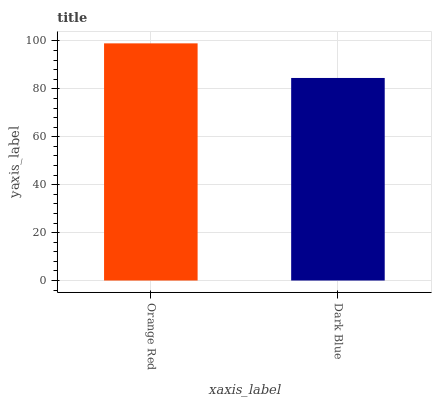Is Dark Blue the minimum?
Answer yes or no. Yes. Is Orange Red the maximum?
Answer yes or no. Yes. Is Dark Blue the maximum?
Answer yes or no. No. Is Orange Red greater than Dark Blue?
Answer yes or no. Yes. Is Dark Blue less than Orange Red?
Answer yes or no. Yes. Is Dark Blue greater than Orange Red?
Answer yes or no. No. Is Orange Red less than Dark Blue?
Answer yes or no. No. Is Orange Red the high median?
Answer yes or no. Yes. Is Dark Blue the low median?
Answer yes or no. Yes. Is Dark Blue the high median?
Answer yes or no. No. Is Orange Red the low median?
Answer yes or no. No. 